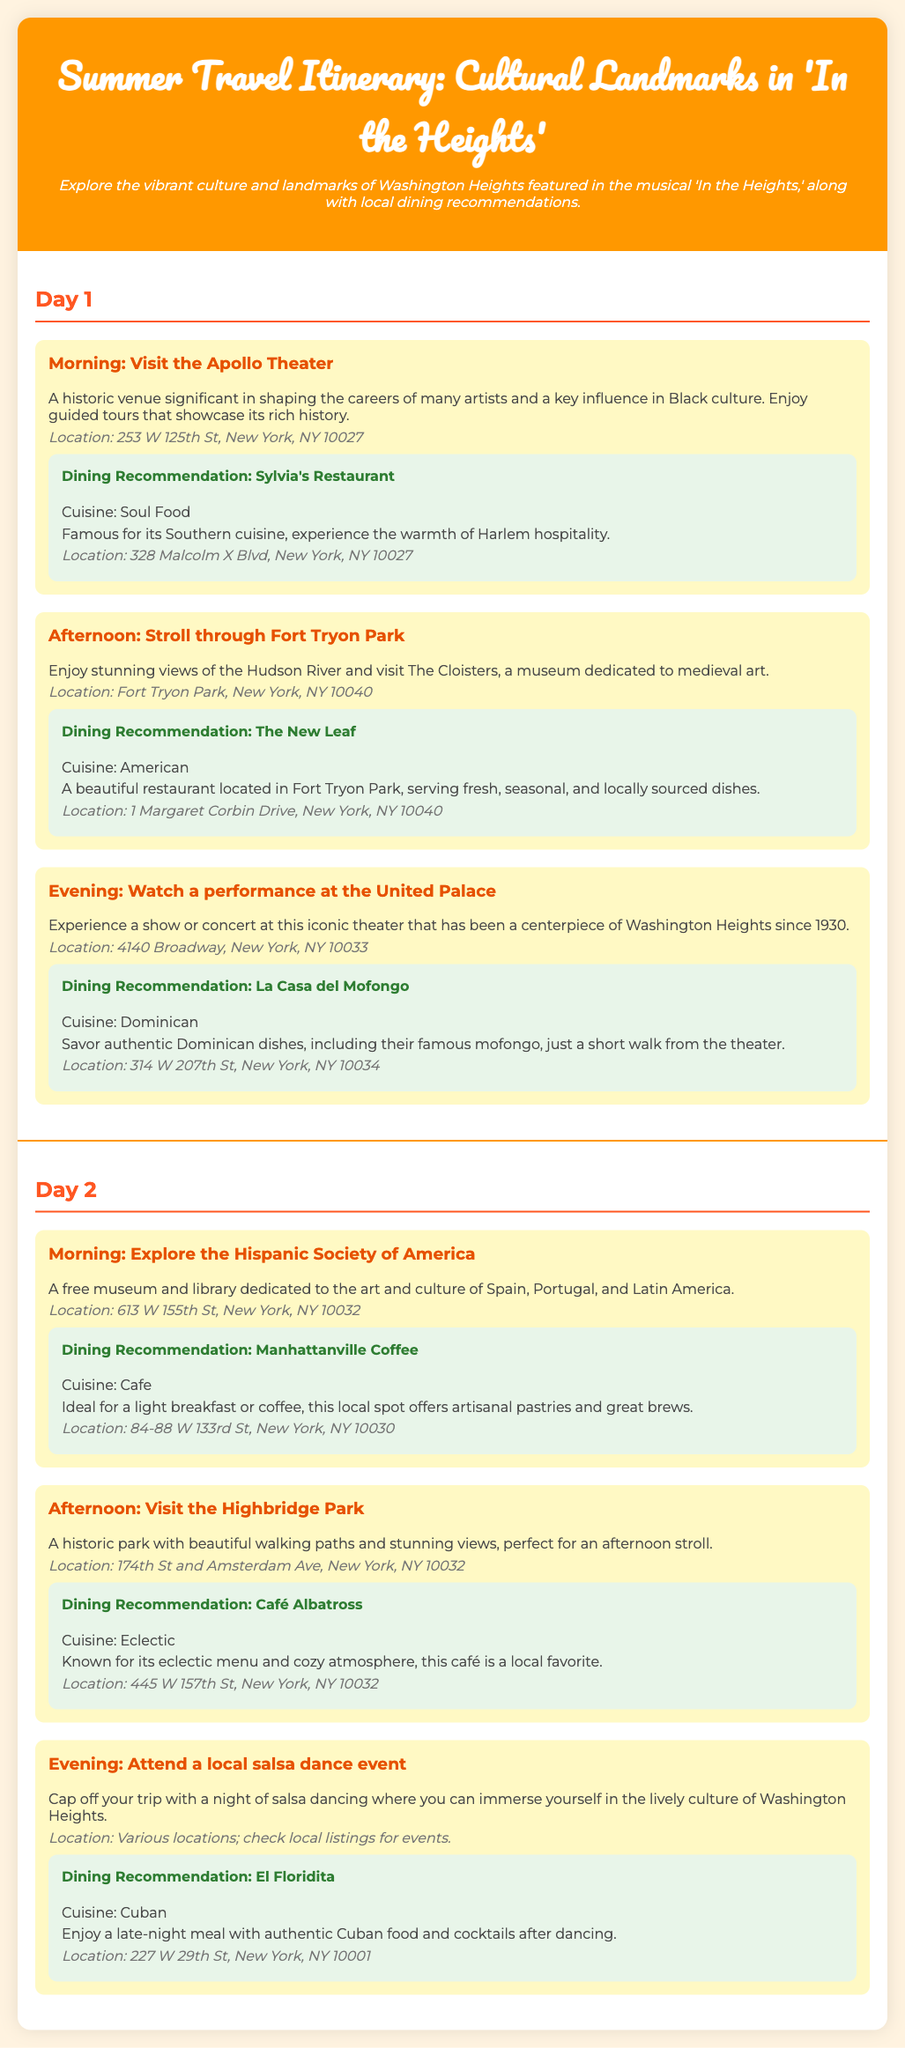What is the title of the itinerary? The title states the focus of the document, which is a travel itinerary for cultural landmarks featured in the musical.
Answer: Summer Travel Itinerary: Cultural Landmarks in 'In the Heights' What is the cuisine of Sylvia's Restaurant? This question asks for the type of food offered at a recommended dining location.
Answer: Soul Food Where is The New Leaf located? This question seeks the specific address of the dining recommendation associated with an afternoon activity.
Answer: 1 Margaret Corbin Drive, New York, NY 10040 What activity is scheduled for Day 2 morning? This question requires identifying the specific cultural activity planned for the first part of the second day.
Answer: Explore the Hispanic Society of America What local event can cap off the trip? This question inquires about a cultural experience that completes the trip and is distinctive to the document's context.
Answer: Attend a local salsa dance event How many activities are listed for Day 1? This requires counting the number of individual activities provided for the first day of the itinerary.
Answer: Three What is the location of the Apollo Theater? This question retrieves the specific address for a highlighted landmark in the cultural itinerary.
Answer: 253 W 125th St, New York, NY 10027 What type of cuisine is offered at El Floridita? This question seeks to know the type of food served at a dinner recommendation for the nighttime activity.
Answer: Cuban What is featured in The Cloisters? This asks for the main focus of a notable location mentioned in the itinerary during Day 1's afternoon activity.
Answer: Medieval art 